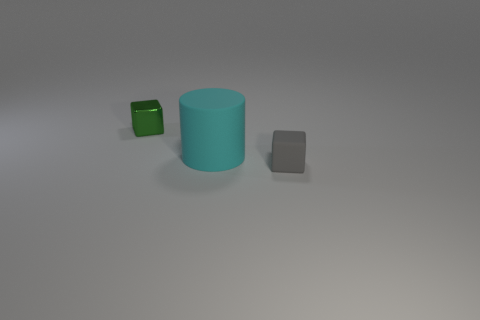Add 3 tiny green shiny cubes. How many objects exist? 6 Subtract all blocks. How many objects are left? 1 Subtract all metallic blocks. Subtract all cyan rubber objects. How many objects are left? 1 Add 2 gray cubes. How many gray cubes are left? 3 Add 2 gray matte things. How many gray matte things exist? 3 Subtract 0 green balls. How many objects are left? 3 